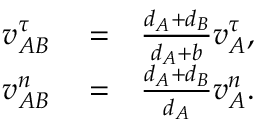<formula> <loc_0><loc_0><loc_500><loc_500>\begin{array} { r l r } { v _ { A B } ^ { \tau } } & = } & { \frac { d _ { A } + d _ { B } } { d _ { A } + b } v _ { A } ^ { \tau } , } \\ { v _ { A B } ^ { n } } & = } & { \frac { d _ { A } + d _ { B } } { d _ { A } } v _ { A } ^ { n } . } \end{array}</formula> 